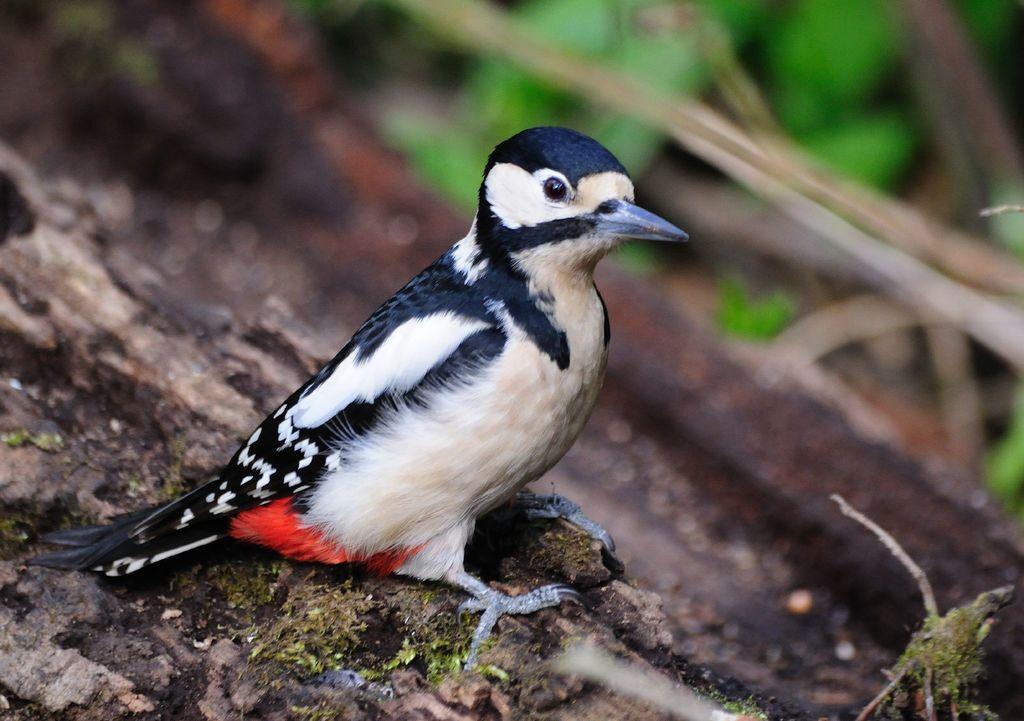Could you give a brief overview of what you see in this image? This image is taken outdoors. At the bottom of the image there is a bark. In the middle of the image there is a bird on the bark. 